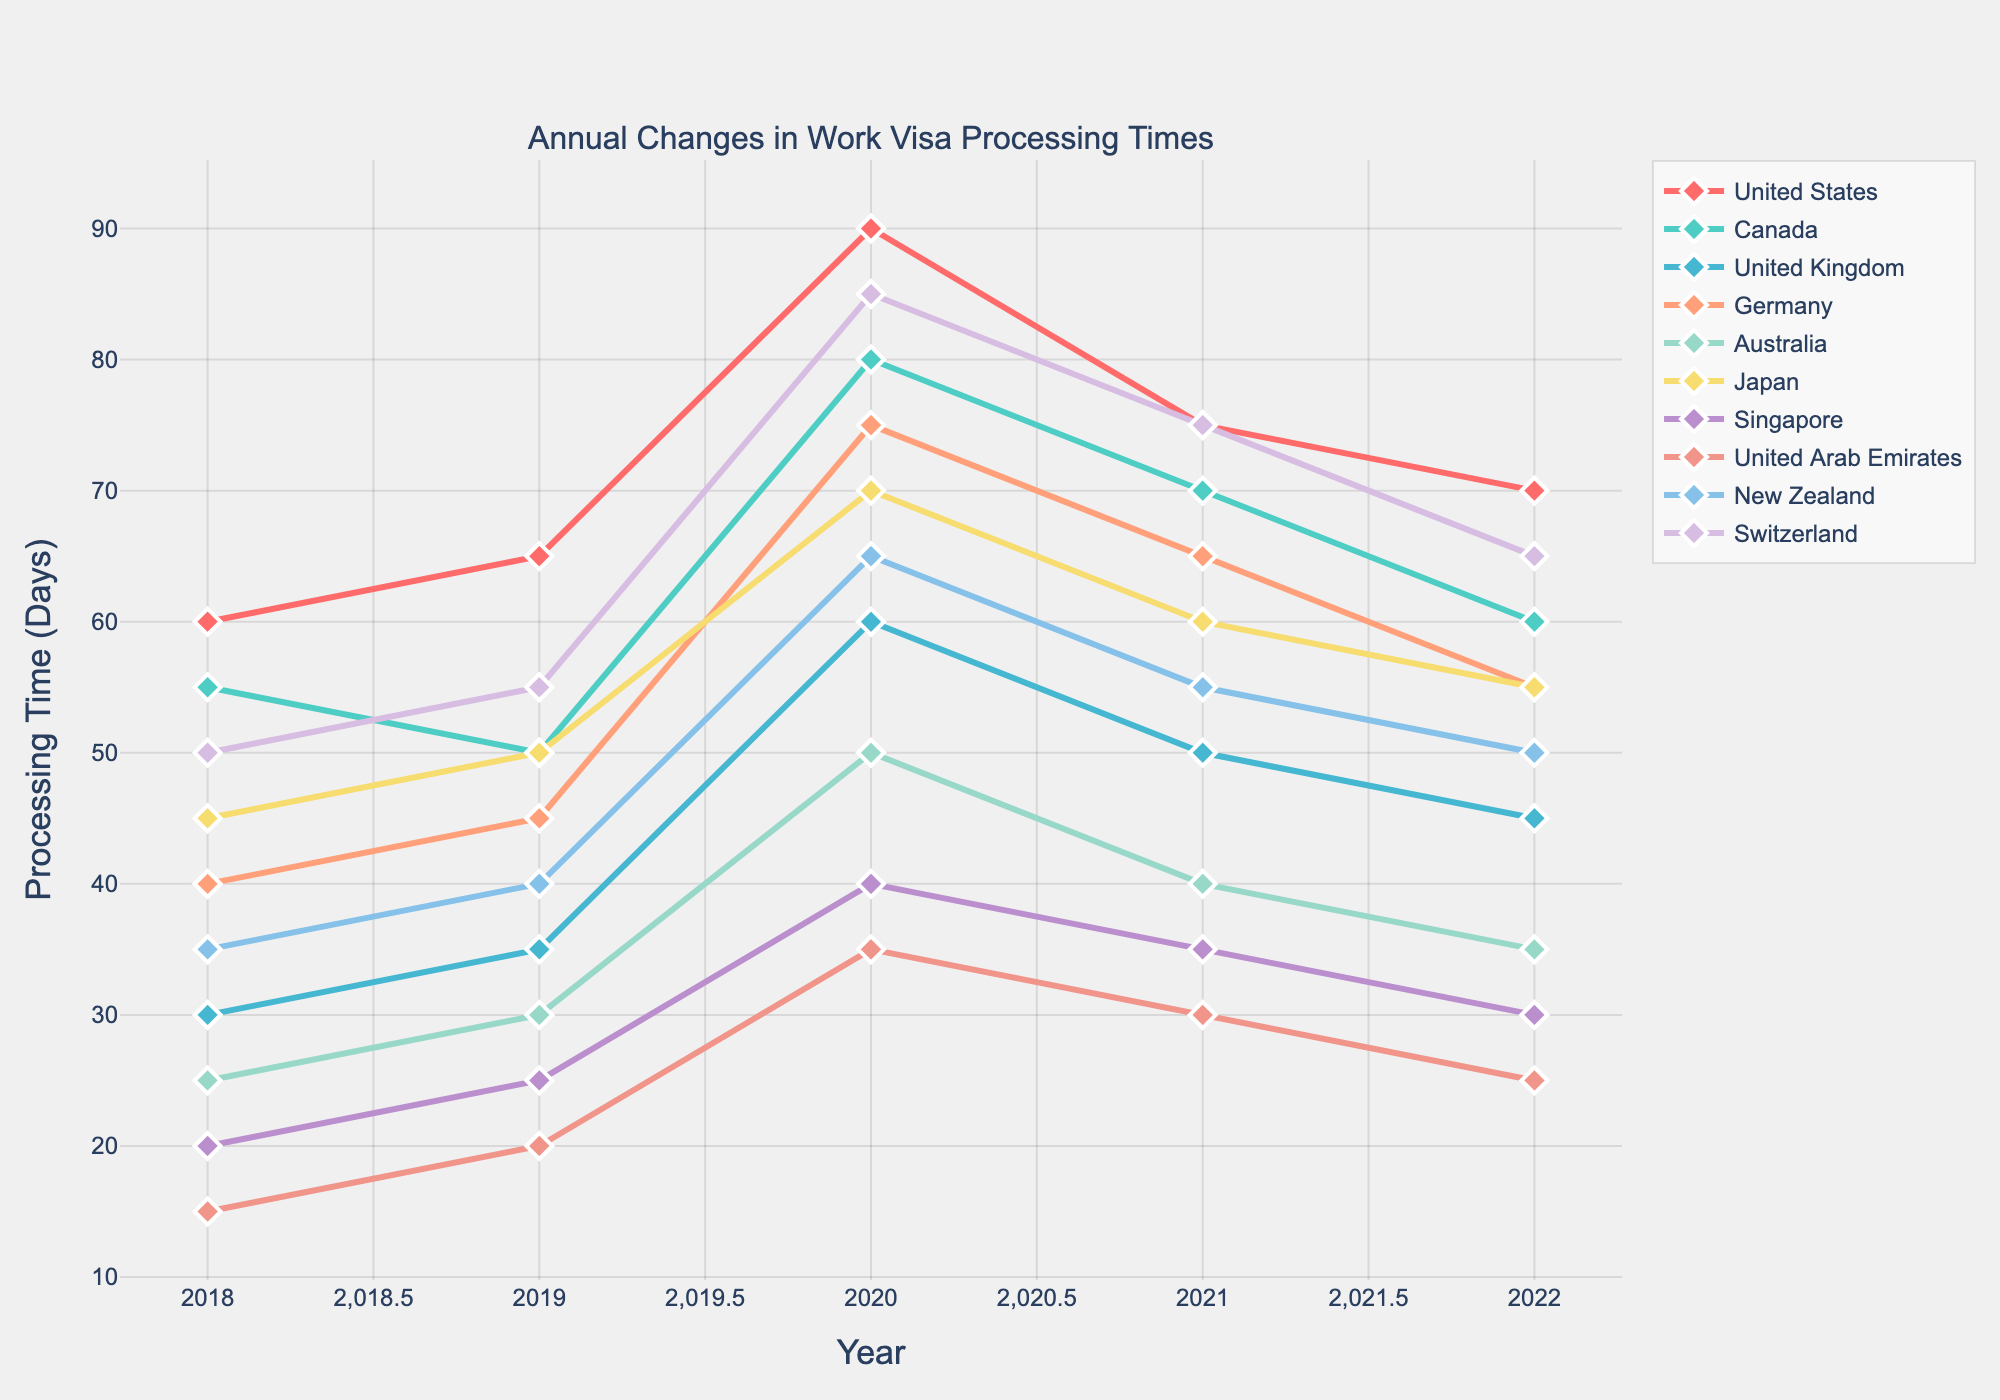What country had the longest visa processing time in 2020? By looking at the figure, the highest point in the 2020 timeline corresponds to the United States with a processing time of 90 days.
Answer: United States Which two countries had the same processing times in 2022? In 2022, by comparing the points of each country, Japan and Germany both have a processing time of 55 days.
Answer: Japan and Germany Which country experienced the largest increase in visa processing time between 2018 and 2020? To find the largest increase, calculate the difference between the 2020 and 2018 values for each country and find the maximum difference. The United States increased from 60 to 90 days, an increase of 30 days.
Answer: United States What was the average processing time for Canada from 2018 to 2022? Sum the processing times for Canada (55 + 50 + 80 + 70 + 60 = 315) and divide by the number of years (5).
Answer: 63 days Which country saw a decrease in processing time each year from 2020 to 2022? By looking at the trend lines, Singapore saw a consistent decrease from 2020 (40) to 2021 (35) to 2022 (30).
Answer: Singapore How did the processing time in Australia change from 2018 to 2022? In 2018, the time was 25 days, and by 2022 it was 35 days. Subtract the 2018 time from the 2022 time (35 - 25 = 10).
Answer: Increased by 10 days Which country had the smallest processing time in 2021? By looking at the points for 2021, the United Arab Emirates has the smallest value at 30 days.
Answer: United Arab Emirates Which country's processing time peaked the highest in a specific year? Examine each year’s highest point, the United States in 2020 peaked at 90 days, which is higher than any other country in any other year.
Answer: United States 